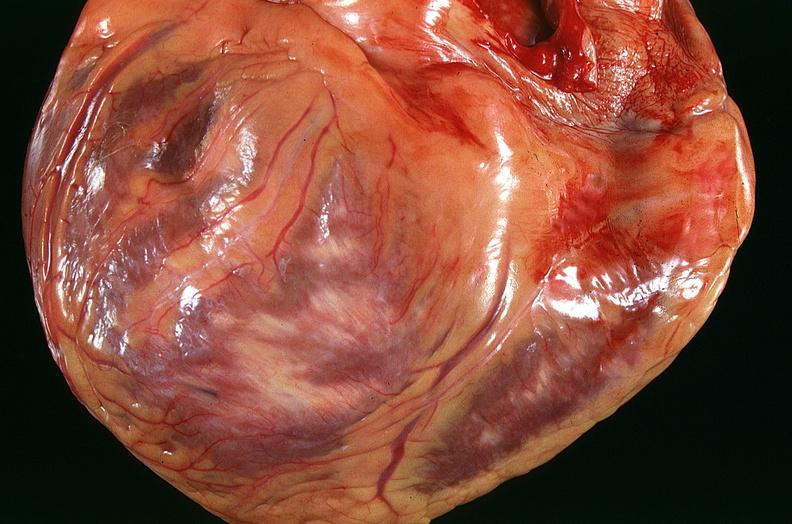what is present?
Answer the question using a single word or phrase. Cardiovascular 